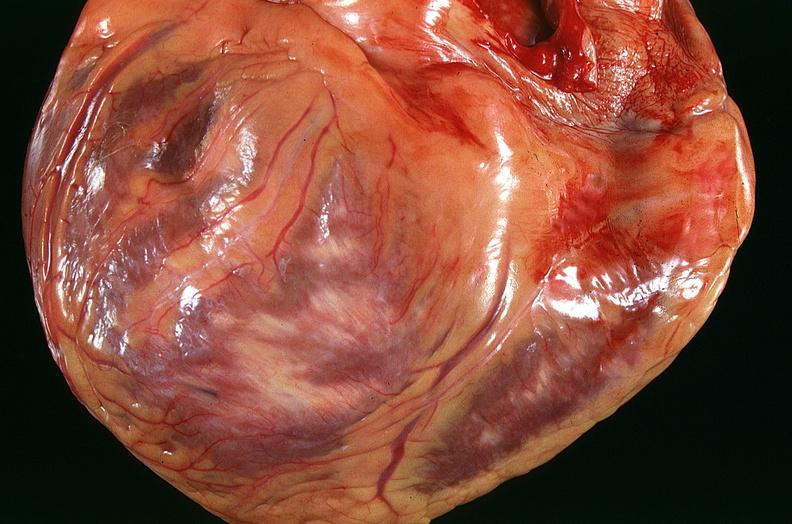what is present?
Answer the question using a single word or phrase. Cardiovascular 